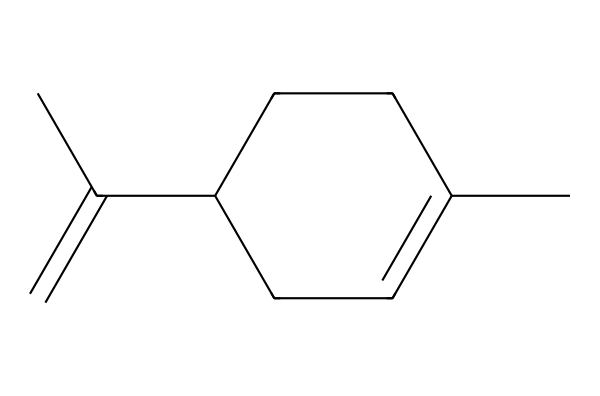What is the molecular formula of limonene? By analyzing the structure, we count the number of carbons (C) and hydrogens (H) in the chemical. The structure contains 10 carbon atoms and 16 hydrogen atoms, leading to the molecular formula C10H16.
Answer: C10H16 How many double bonds are present in the structure of limonene? Looking at the structure, we identify the positions of any double bonds between carbon atoms. There are two double bonds in the structure of limonene.
Answer: 2 What type of compound is limonene classified as? Based on the functional groups and overall structure, limonene is classified as a terpene due to its arrangement of carbon and hydrogen atoms in a cyclic structure with double bonds.
Answer: terpene What is the saturation level of the carbon atoms in limonene? Examining the double bonds in the structure indicates that the carbon atoms are not fully saturated compared to alkanes; limonene contains two double bonds, defining it as an unsaturated compound.
Answer: unsaturated How many rings are present in the limonene structure? Observing the cyclic formation in the structure, there is one ring formed by carbon atoms in limonene.
Answer: 1 What is the primary characteristic smell associated with limonene? Limonene is primarily characterized by a citrus scent, commonly associated with lemons and oranges because of its presence in these essential oils.
Answer: citrus scent What is the stereochemistry of limonene? The arrangement of the carbon atoms with respect to their substituents indicates that limonene exists in two enantiomers, with the most common form being (R)-limonene, which has a specific spatial arrangement.
Answer: chiral 